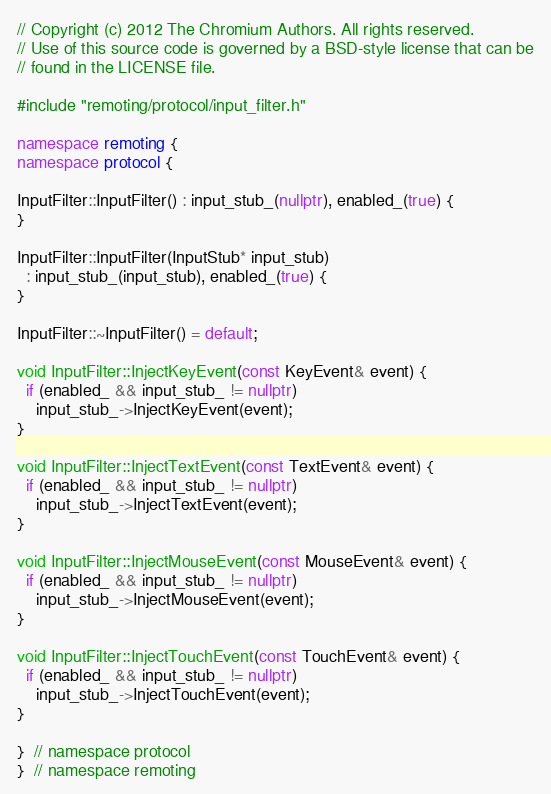<code> <loc_0><loc_0><loc_500><loc_500><_C++_>// Copyright (c) 2012 The Chromium Authors. All rights reserved.
// Use of this source code is governed by a BSD-style license that can be
// found in the LICENSE file.

#include "remoting/protocol/input_filter.h"

namespace remoting {
namespace protocol {

InputFilter::InputFilter() : input_stub_(nullptr), enabled_(true) {
}

InputFilter::InputFilter(InputStub* input_stub)
  : input_stub_(input_stub), enabled_(true) {
}

InputFilter::~InputFilter() = default;

void InputFilter::InjectKeyEvent(const KeyEvent& event) {
  if (enabled_ && input_stub_ != nullptr)
    input_stub_->InjectKeyEvent(event);
}

void InputFilter::InjectTextEvent(const TextEvent& event) {
  if (enabled_ && input_stub_ != nullptr)
    input_stub_->InjectTextEvent(event);
}

void InputFilter::InjectMouseEvent(const MouseEvent& event) {
  if (enabled_ && input_stub_ != nullptr)
    input_stub_->InjectMouseEvent(event);
}

void InputFilter::InjectTouchEvent(const TouchEvent& event) {
  if (enabled_ && input_stub_ != nullptr)
    input_stub_->InjectTouchEvent(event);
}

}  // namespace protocol
}  // namespace remoting
</code> 